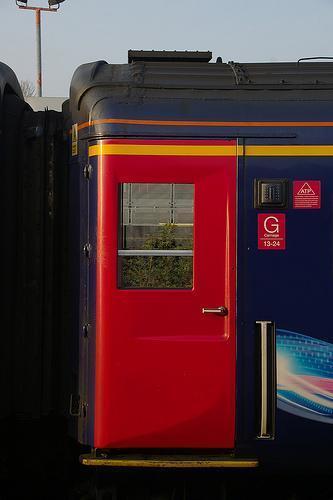How many windows on the door?
Give a very brief answer. 1. How many red doors can you see?
Give a very brief answer. 1. 